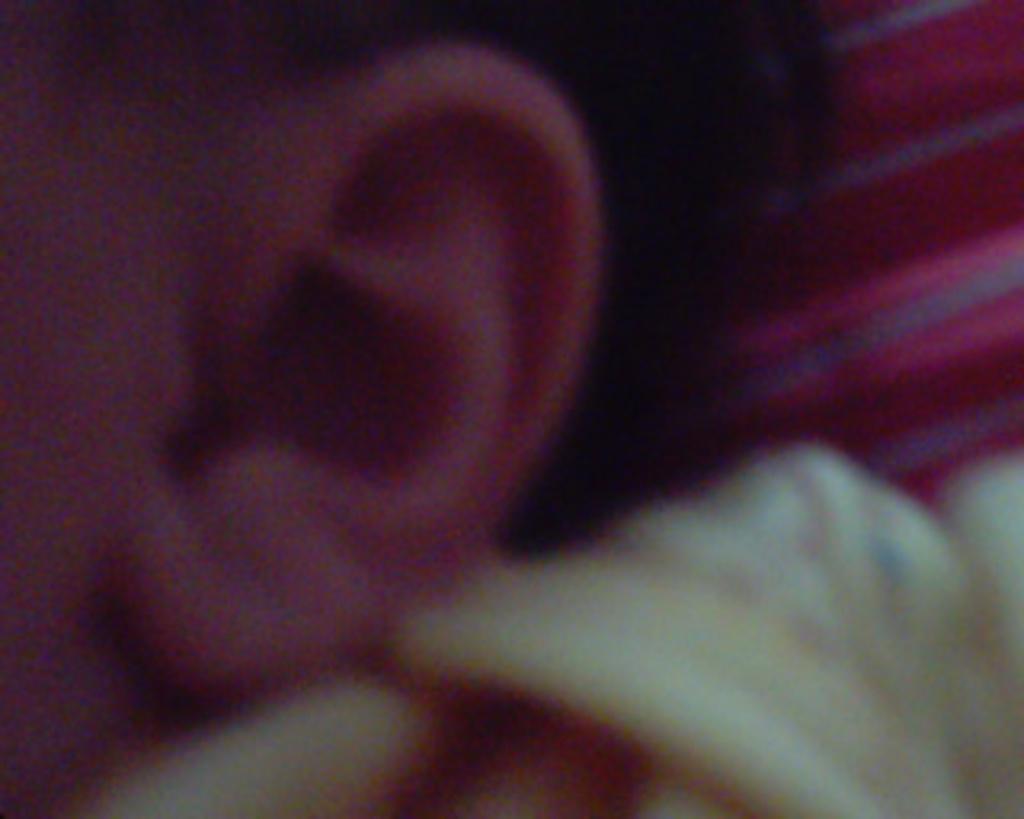Please provide a concise description of this image. In this picture we can see ear of a person. 